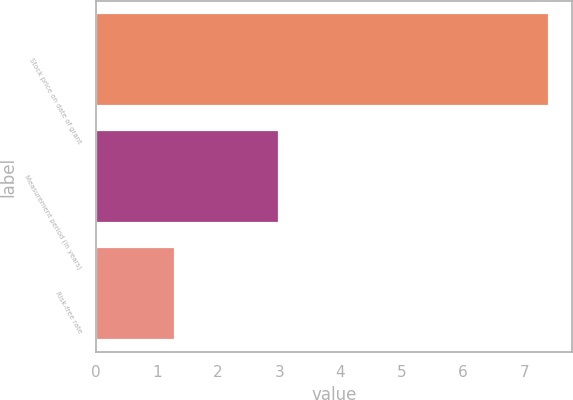Convert chart. <chart><loc_0><loc_0><loc_500><loc_500><bar_chart><fcel>Stock price on date of grant<fcel>Measurement period (in years)<fcel>Risk-free rate<nl><fcel>7.41<fcel>3<fcel>1.29<nl></chart> 